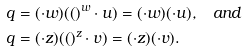<formula> <loc_0><loc_0><loc_500><loc_500>q & = ( \cdot w ) ( ( ) ^ { w } \cdot u ) = ( \cdot w ) ( \cdot u ) , \quad a n d \\ q & = ( \cdot z ) ( ( ) ^ { z } \cdot v ) = ( \cdot z ) ( \cdot v ) .</formula> 